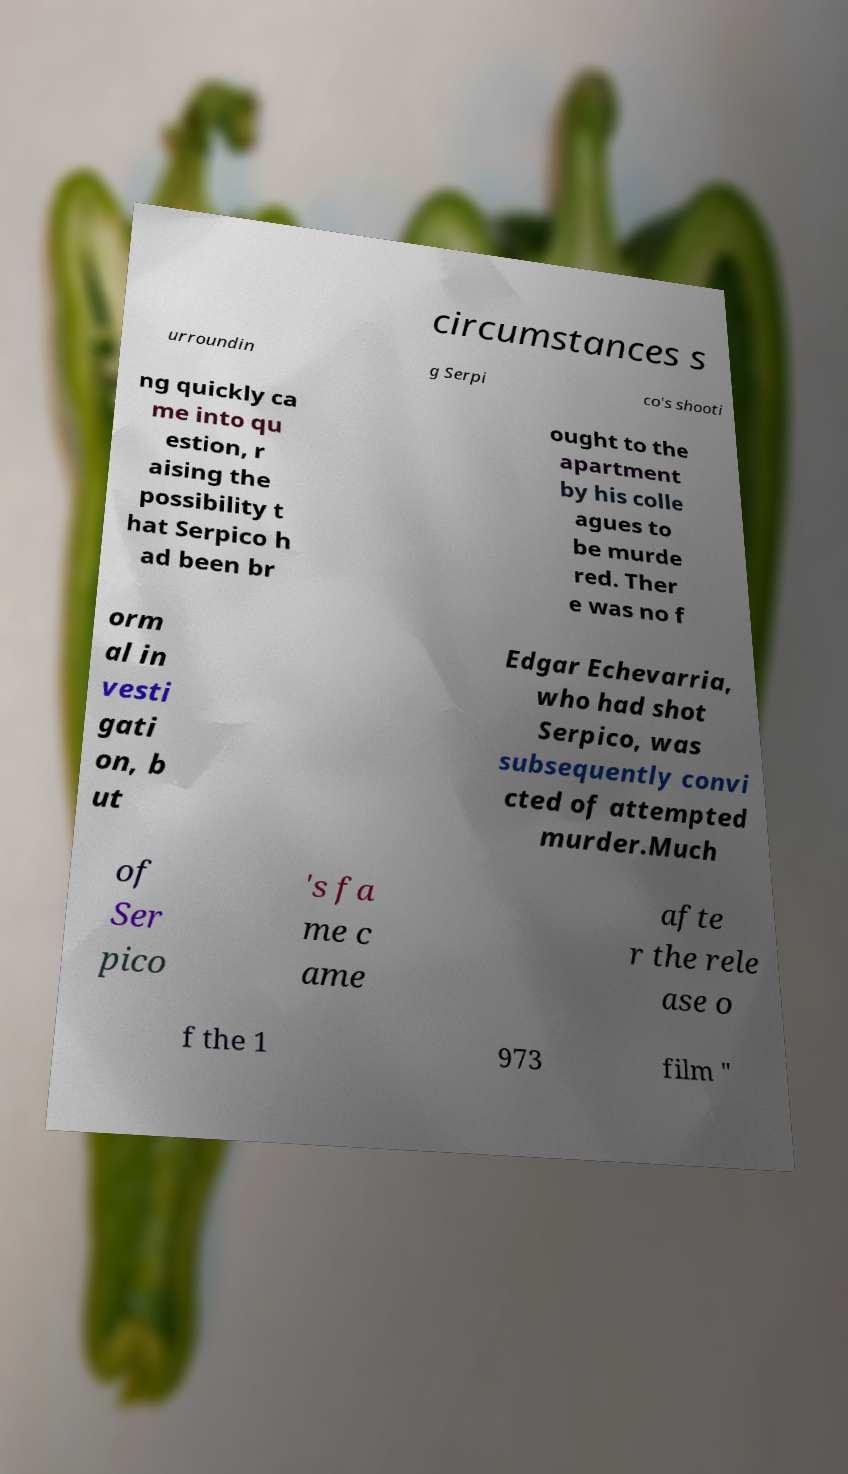What messages or text are displayed in this image? I need them in a readable, typed format. circumstances s urroundin g Serpi co's shooti ng quickly ca me into qu estion, r aising the possibility t hat Serpico h ad been br ought to the apartment by his colle agues to be murde red. Ther e was no f orm al in vesti gati on, b ut Edgar Echevarria, who had shot Serpico, was subsequently convi cted of attempted murder.Much of Ser pico 's fa me c ame afte r the rele ase o f the 1 973 film " 